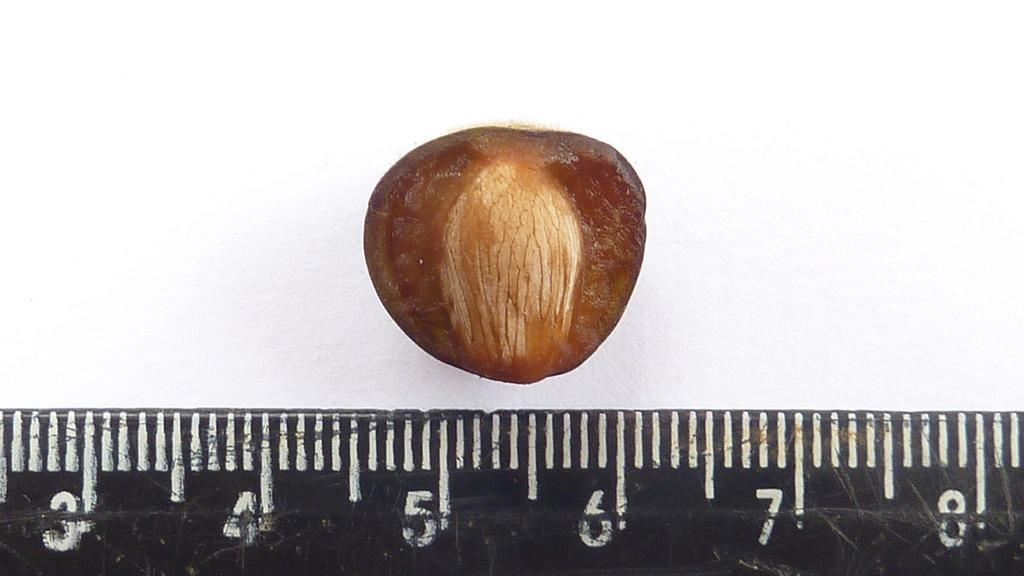<image>
Offer a succinct explanation of the picture presented. Something, perhaps a nut being measured on a measuring tape between the five inch mark and the 6 inch mark. 